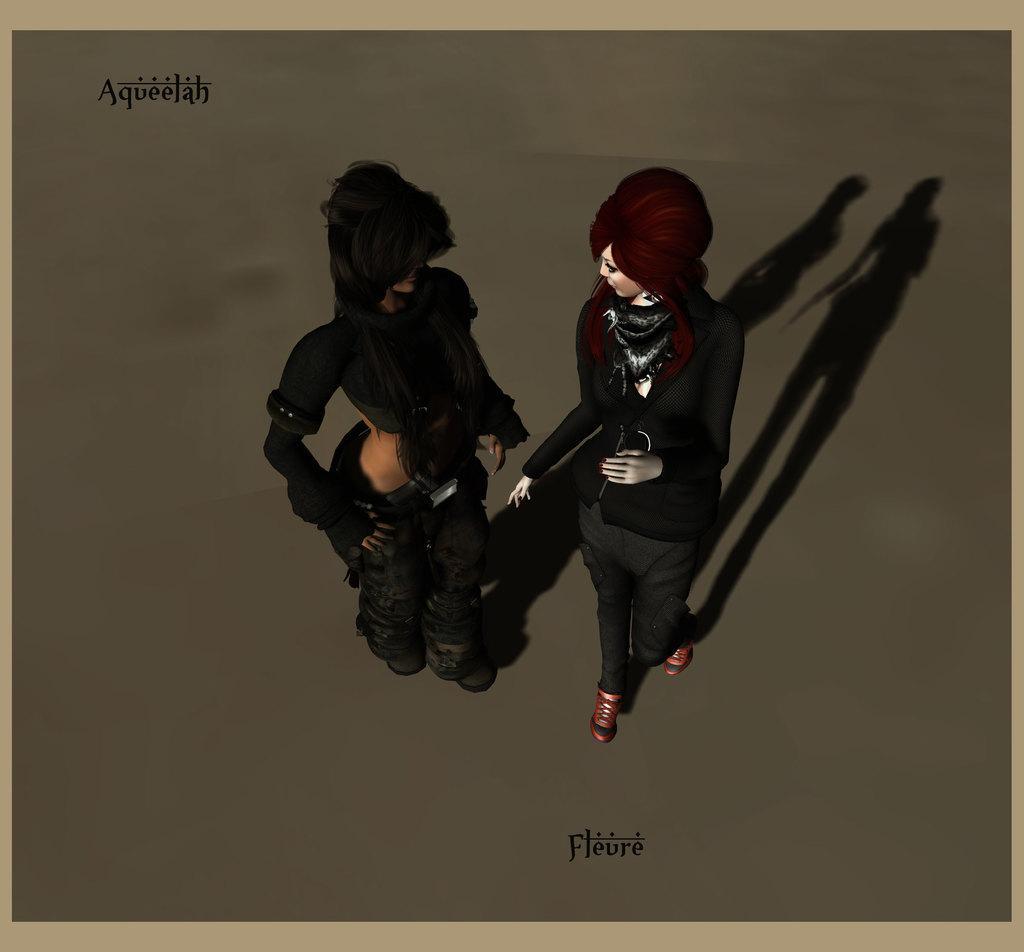Could you give a brief overview of what you see in this image? This is an animation image which consists of three people and on the top left corner and bottom of the image some text is written. 